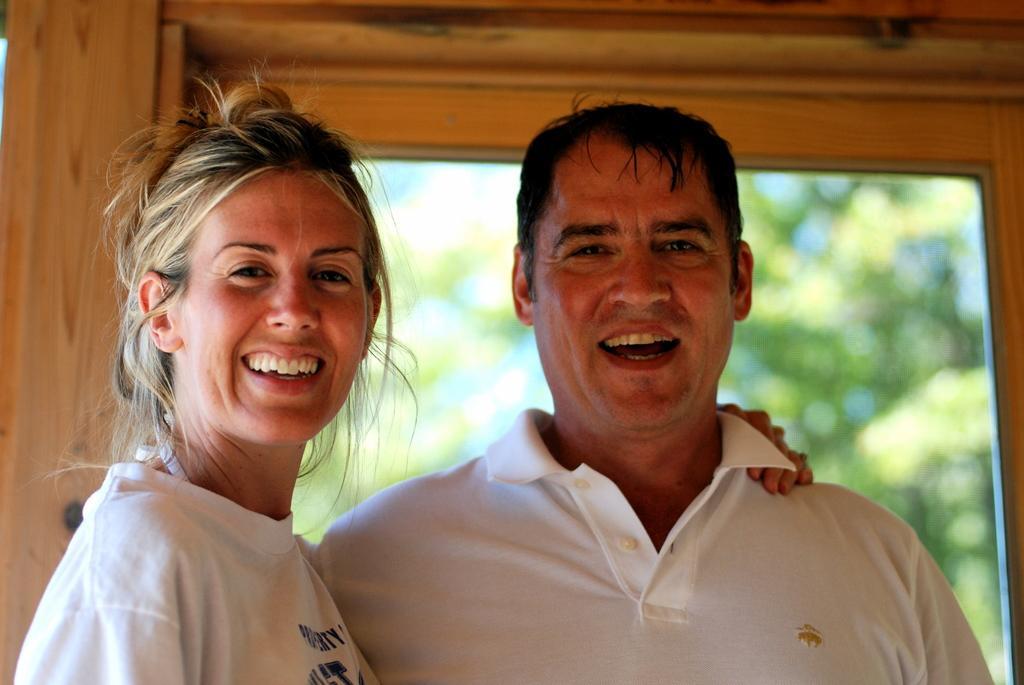Please provide a concise description of this image. In the picture i can see a man and woman wearing white color T-shirt standing and in the background there are some trees. 